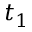<formula> <loc_0><loc_0><loc_500><loc_500>t _ { 1 }</formula> 